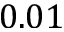Convert formula to latex. <formula><loc_0><loc_0><loc_500><loc_500>0 . 0 1</formula> 